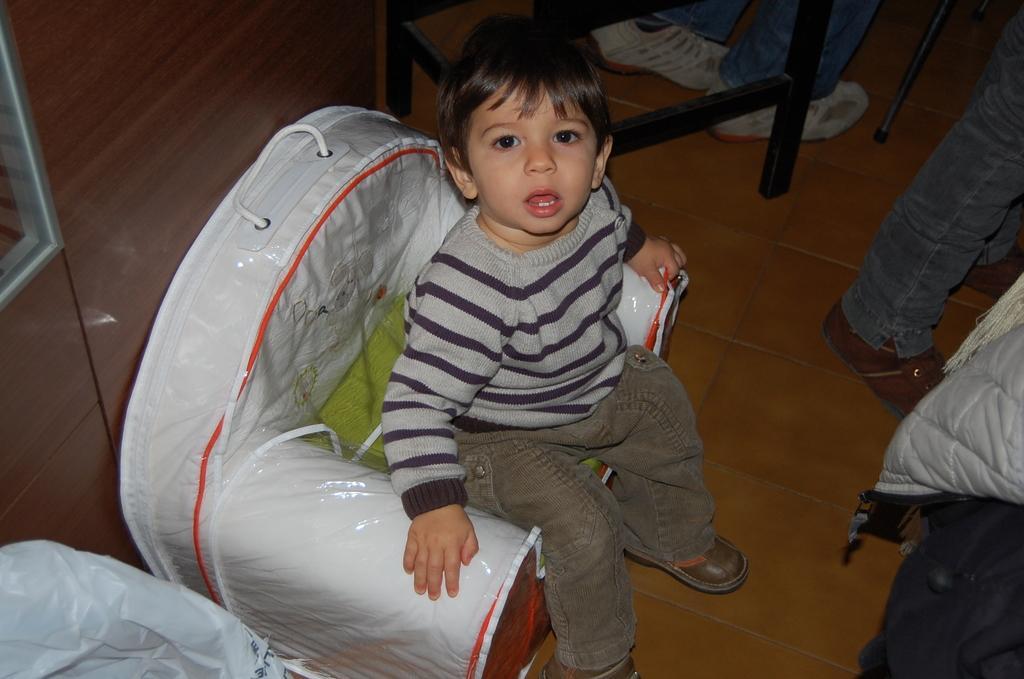Could you give a brief overview of what you see in this image? In this picture we can see a boy siting on chair and beside to him we can see table, some persons leg, jacket, plastic cover and in background we can see wall. 